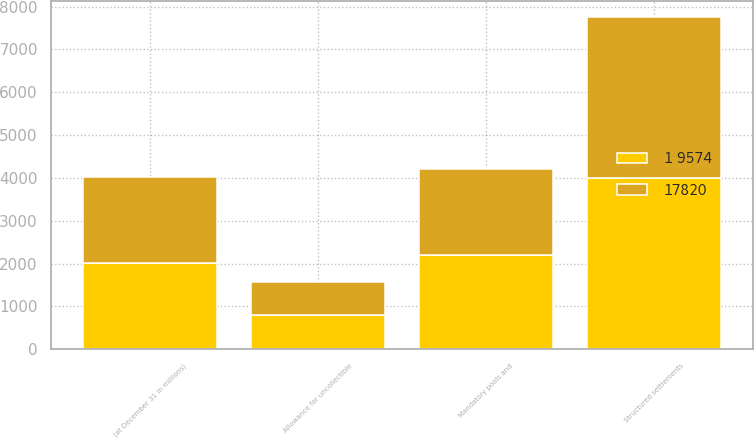<chart> <loc_0><loc_0><loc_500><loc_500><stacked_bar_chart><ecel><fcel>(at December 31 in millions)<fcel>Allowance for uncollectible<fcel>Structured settlements<fcel>Mandatory pools and<nl><fcel>17820<fcel>2006<fcel>773<fcel>3758<fcel>1998<nl><fcel>1 9574<fcel>2005<fcel>804<fcel>3990<fcel>2211<nl></chart> 